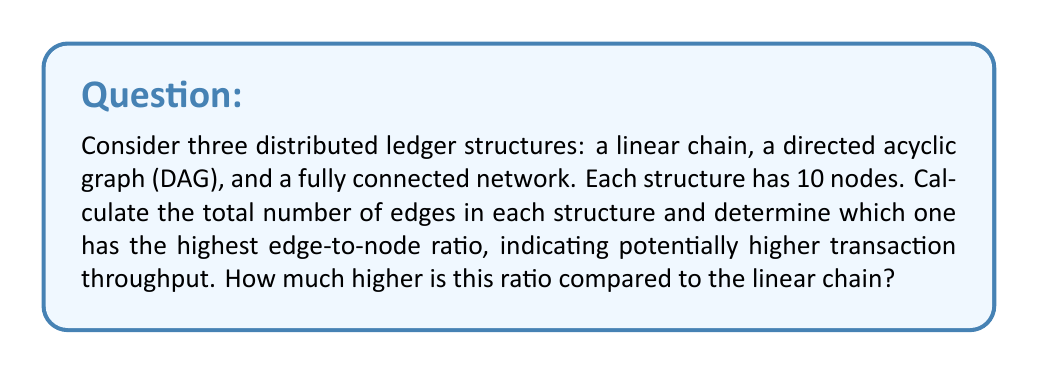What is the answer to this math problem? Let's analyze each structure:

1. Linear Chain:
   In a linear chain, each node is connected to the next one.
   Number of edges = $n - 1$, where $n$ is the number of nodes.
   Edges = $10 - 1 = 9$
   Edge-to-node ratio = $\frac{9}{10} = 0.9$

2. Directed Acyclic Graph (DAG):
   In a typical DAG for distributed ledgers, each node connects to approximately half of the subsequent nodes.
   Estimated edges = $\frac{n(n-1)}{4}$
   Edges ≈ $\frac{10(10-1)}{4} = \frac{90}{4} = 22.5$ (rounded to 23)
   Edge-to-node ratio = $\frac{23}{10} = 2.3$

3. Fully Connected Network:
   In a fully connected network, each node connects to every other node.
   Number of edges = $\frac{n(n-1)}{2}$
   Edges = $\frac{10(10-1)}{2} = \frac{90}{2} = 45$
   Edge-to-node ratio = $\frac{45}{10} = 4.5$

The fully connected network has the highest edge-to-node ratio at 4.5.

To calculate how much higher this ratio is compared to the linear chain:

$$\text{Difference} = \frac{\text{Fully Connected Ratio}}{\text{Linear Chain Ratio}} = \frac{4.5}{0.9} = 5$$

Therefore, the fully connected network's edge-to-node ratio is 5 times higher than the linear chain's ratio.
Answer: The fully connected network has the highest edge-to-node ratio at 4.5, which is 5 times higher than the linear chain's ratio. 